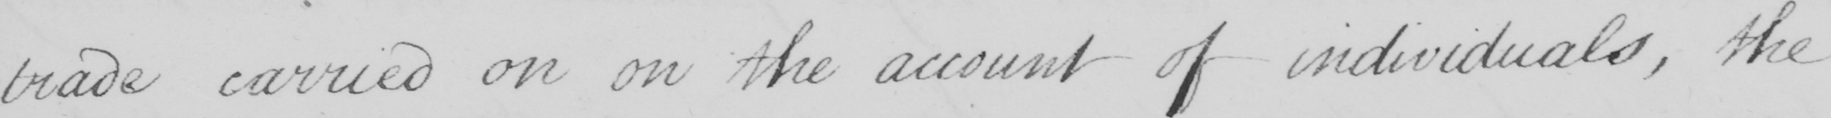What text is written in this handwritten line? trade carried on on the account of individuals , the 